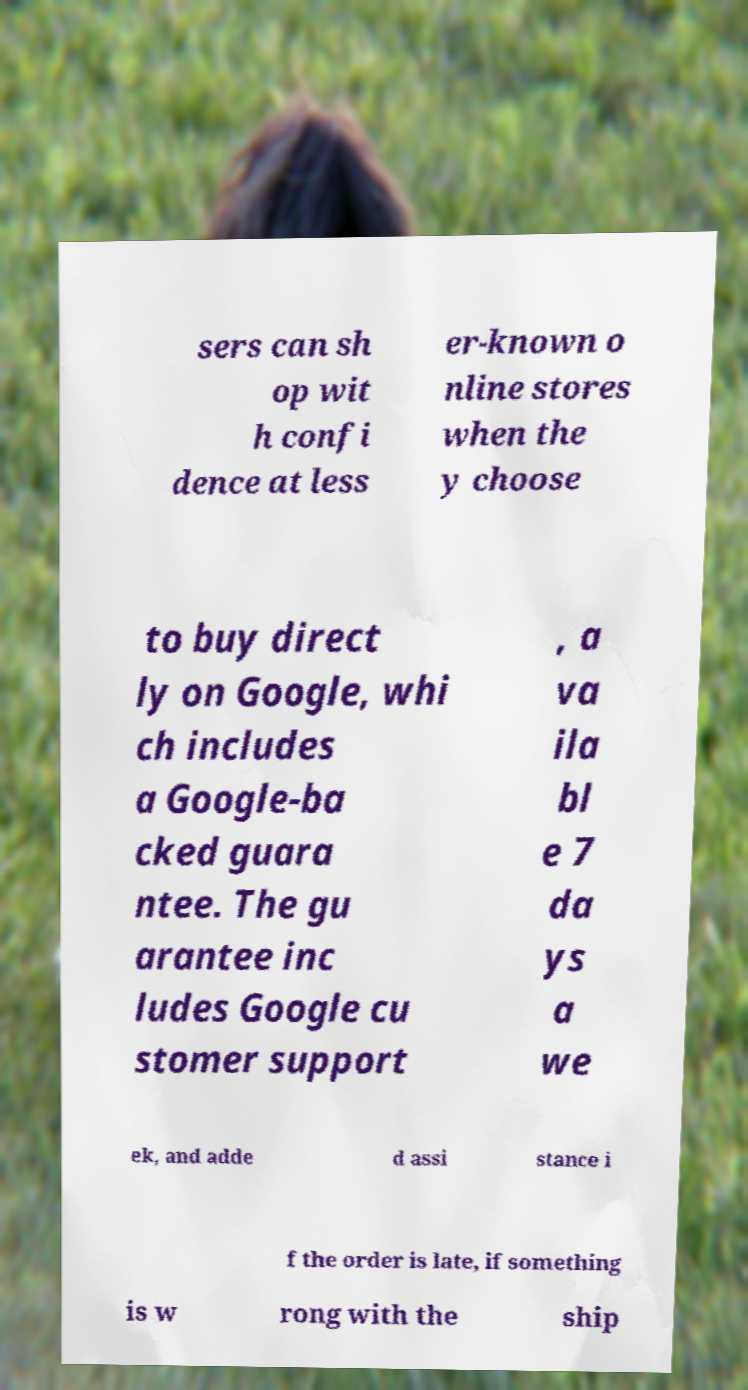Could you extract and type out the text from this image? sers can sh op wit h confi dence at less er-known o nline stores when the y choose to buy direct ly on Google, whi ch includes a Google-ba cked guara ntee. The gu arantee inc ludes Google cu stomer support , a va ila bl e 7 da ys a we ek, and adde d assi stance i f the order is late, if something is w rong with the ship 